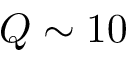Convert formula to latex. <formula><loc_0><loc_0><loc_500><loc_500>Q \sim 1 0</formula> 